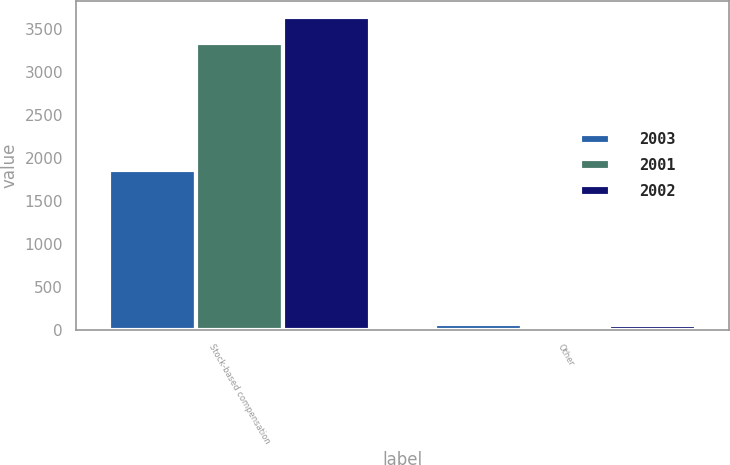Convert chart. <chart><loc_0><loc_0><loc_500><loc_500><stacked_bar_chart><ecel><fcel>Stock-based compensation<fcel>Other<nl><fcel>2003<fcel>1864<fcel>64<nl><fcel>2001<fcel>3343<fcel>15<nl><fcel>2002<fcel>3644<fcel>56<nl></chart> 